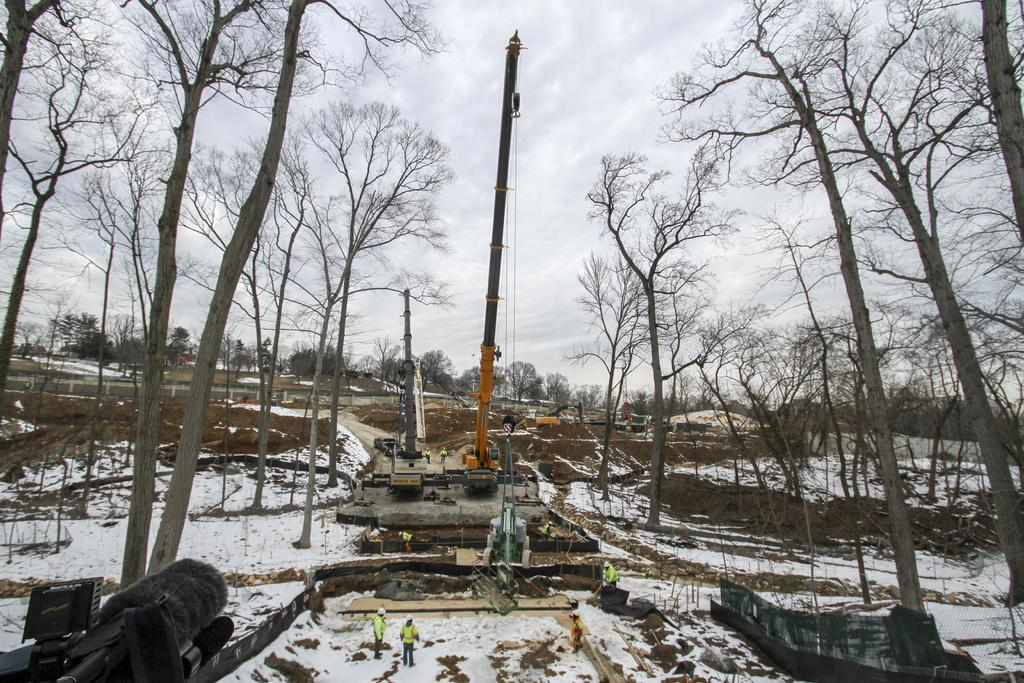What can be seen in the image related to transportation? There are vehicles in the image. What activity are people engaged in within the image? People are working on the snow in the image. What type of natural environment is present in the image? There are trees around the area in the image. Can you see anyone talking to the trees in the image? There is no indication in the image that anyone is talking to the trees. Are there any umbrellas visible in the image? There is no mention of umbrellas in the provided facts, and therefore we cannot determine if any are present in the image. 